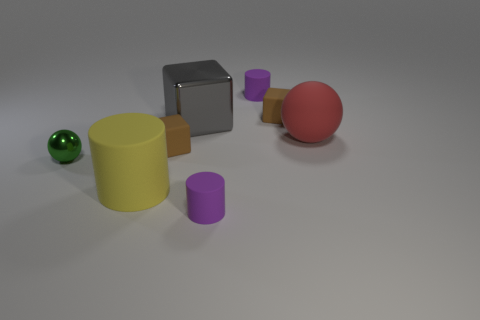Can you speculate on the material the objects might be made of? The objects appear to have a smooth and matte surface, suggesting they could be made of plastic or a similarly non-reflective material. 